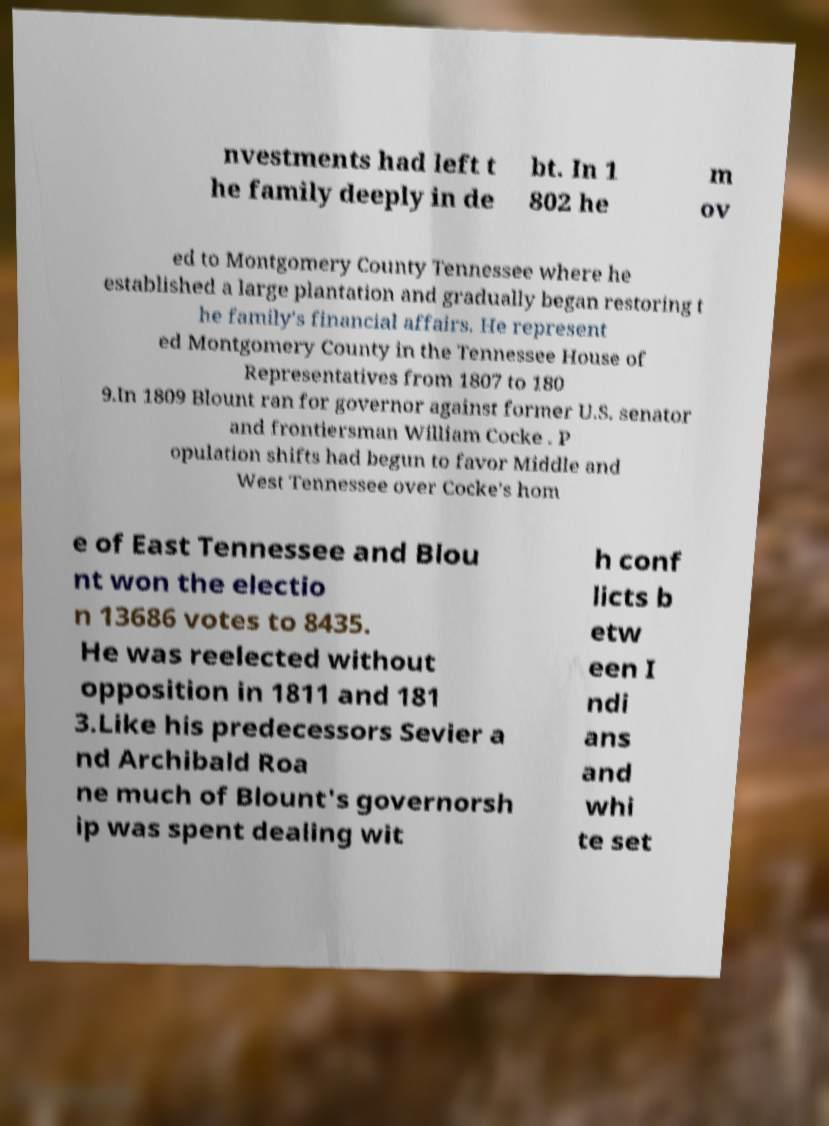What messages or text are displayed in this image? I need them in a readable, typed format. nvestments had left t he family deeply in de bt. In 1 802 he m ov ed to Montgomery County Tennessee where he established a large plantation and gradually began restoring t he family's financial affairs. He represent ed Montgomery County in the Tennessee House of Representatives from 1807 to 180 9.In 1809 Blount ran for governor against former U.S. senator and frontiersman William Cocke . P opulation shifts had begun to favor Middle and West Tennessee over Cocke's hom e of East Tennessee and Blou nt won the electio n 13686 votes to 8435. He was reelected without opposition in 1811 and 181 3.Like his predecessors Sevier a nd Archibald Roa ne much of Blount's governorsh ip was spent dealing wit h conf licts b etw een I ndi ans and whi te set 